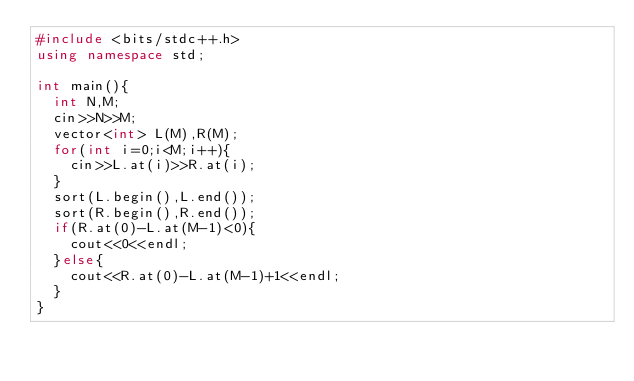Convert code to text. <code><loc_0><loc_0><loc_500><loc_500><_C++_>#include <bits/stdc++.h>
using namespace std;

int main(){
  int N,M;
  cin>>N>>M;
  vector<int> L(M),R(M);
  for(int i=0;i<M;i++){
    cin>>L.at(i)>>R.at(i);
  }
  sort(L.begin(),L.end());
  sort(R.begin(),R.end());
  if(R.at(0)-L.at(M-1)<0){
    cout<<0<<endl;
  }else{
    cout<<R.at(0)-L.at(M-1)+1<<endl;
  }
}
</code> 